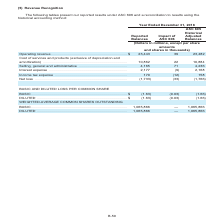According to Centurylink's financial document, The table presents the reported results including the impact of what? According to the financial document, ASC 606. The relevant text states: "llowing tables present our reported results under ASC 606 and a reconciliation to results using the historical accounting method:..." Also, What method is used for the reconciliation of results? historical accounting method. The document states: "ASC 606 and a reconciliation to results using the historical accounting method:..." Also, What is the Reported Balances operating revenue? According to the financial document, $23,443 (in millions). The relevant text states: "ts and shares in thousands) Operating revenue . $ 23,443 39 23,482 Cost of services and products (exclusive of depreciation and amortization) . 10,862 22 10..." Also, How many types of weighted-average common shares outstanding are there? Counting the relevant items in the document: Basic, Diluted, I find 2 instances. The key data points involved are: Basic, Diluted. Also, can you calculate: What is the sum of interest expense and income tax expense under the ASC 605 Historical Adjusted Balances? Based on the calculation: 2,168+158, the result is 2326 (in millions). This is based on the information: "ive . 4,165 71 4,236 Interest expense . 2,177 (9) 2,168 Income tax expense . 170 (12) 158 Net loss . (1,733) (33) (1,766) e . 2,177 (9) 2,168 Income tax expense . 170 (12) 158 Net loss . (1,733) (33) ..." The key data points involved are: 158, 2,168. Also, can you calculate: What is the average income tax expense under reported balances and ASC 605 Historical Adjusted Balances? To answer this question, I need to perform calculations using the financial data. The calculation is: (170+158)/2, which equals 164 (in millions). This is based on the information: "st expense . 2,177 (9) 2,168 Income tax expense . 170 (12) 158 Net loss . (1,733) (33) (1,766) e . 2,177 (9) 2,168 Income tax expense . 170 (12) 158 Net loss . (1,733) (33) (1,766)..." The key data points involved are: 158, 170. 